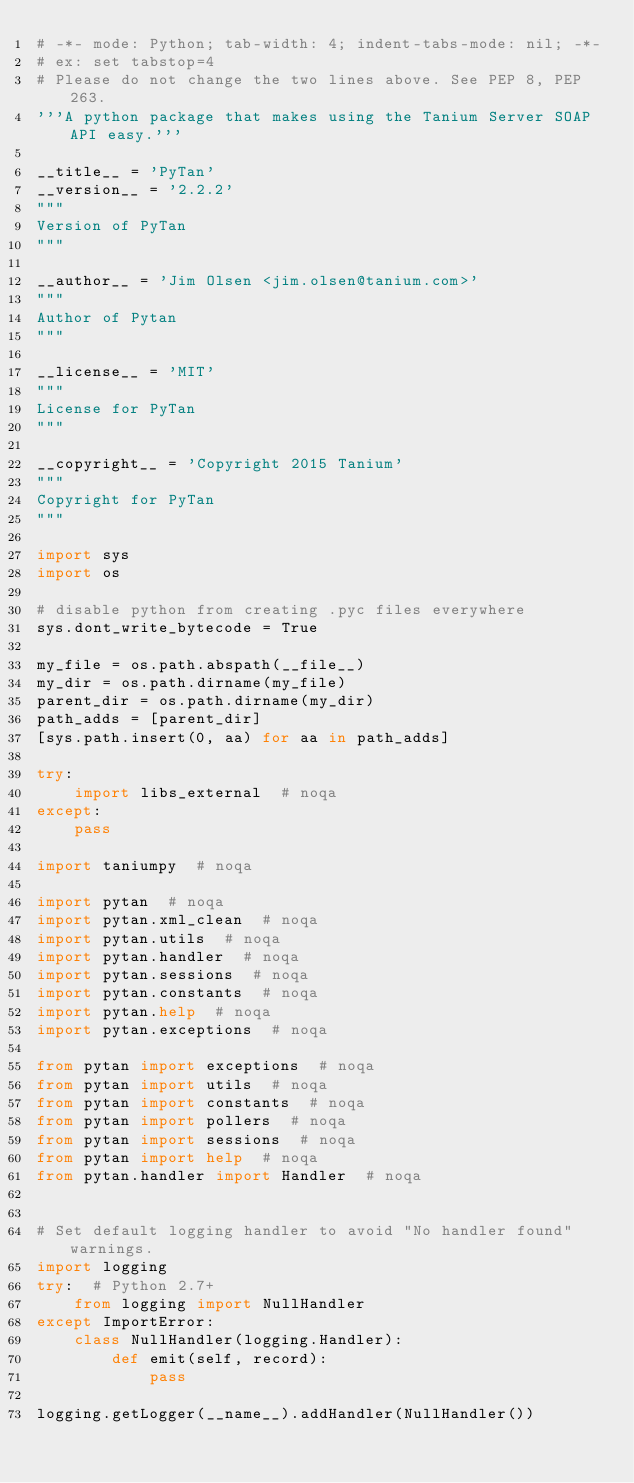<code> <loc_0><loc_0><loc_500><loc_500><_Python_># -*- mode: Python; tab-width: 4; indent-tabs-mode: nil; -*-
# ex: set tabstop=4
# Please do not change the two lines above. See PEP 8, PEP 263.
'''A python package that makes using the Tanium Server SOAP API easy.'''

__title__ = 'PyTan'
__version__ = '2.2.2'
"""
Version of PyTan
"""

__author__ = 'Jim Olsen <jim.olsen@tanium.com>'
"""
Author of Pytan
"""

__license__ = 'MIT'
"""
License for PyTan
"""

__copyright__ = 'Copyright 2015 Tanium'
"""
Copyright for PyTan
"""

import sys
import os

# disable python from creating .pyc files everywhere
sys.dont_write_bytecode = True

my_file = os.path.abspath(__file__)
my_dir = os.path.dirname(my_file)
parent_dir = os.path.dirname(my_dir)
path_adds = [parent_dir]
[sys.path.insert(0, aa) for aa in path_adds]

try:
    import libs_external  # noqa
except:
    pass

import taniumpy  # noqa

import pytan  # noqa
import pytan.xml_clean  # noqa
import pytan.utils  # noqa
import pytan.handler  # noqa
import pytan.sessions  # noqa
import pytan.constants  # noqa
import pytan.help  # noqa
import pytan.exceptions  # noqa

from pytan import exceptions  # noqa
from pytan import utils  # noqa
from pytan import constants  # noqa
from pytan import pollers  # noqa
from pytan import sessions  # noqa
from pytan import help  # noqa
from pytan.handler import Handler  # noqa


# Set default logging handler to avoid "No handler found" warnings.
import logging
try:  # Python 2.7+
    from logging import NullHandler
except ImportError:
    class NullHandler(logging.Handler):
        def emit(self, record):
            pass

logging.getLogger(__name__).addHandler(NullHandler())
</code> 